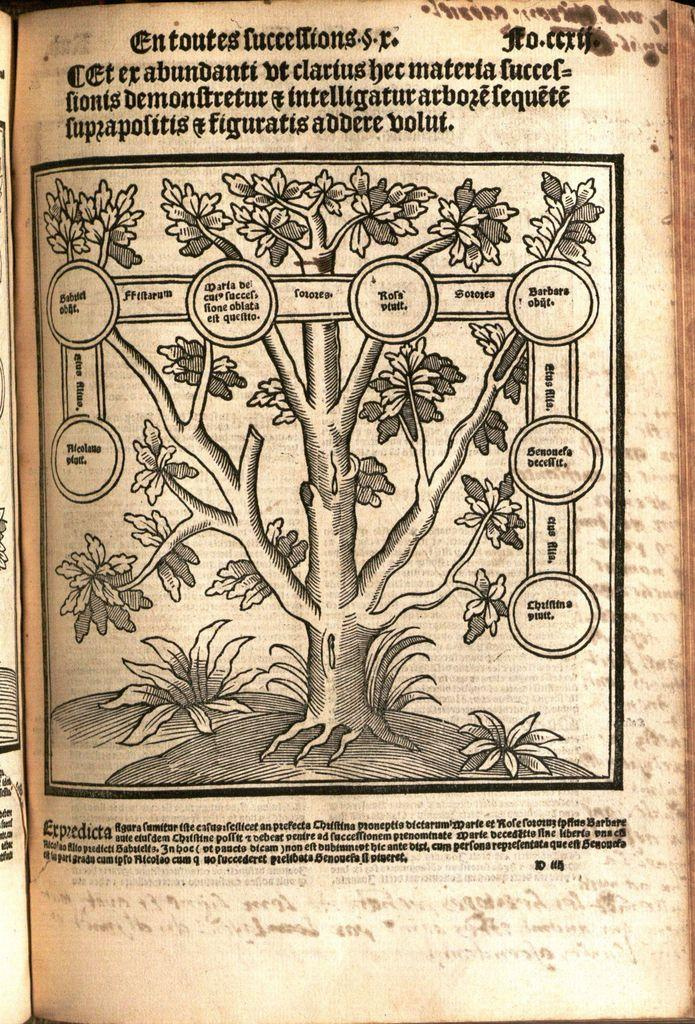What object is present in the image? There is a book in the image. What is depicted in the book? The book contains a picture of a tree. What else can be found in the book besides the picture? The book also contains text. How many feet are mentioned in the book? There are no feet mentioned in the book; it contains a picture of a tree and accompanying text. 